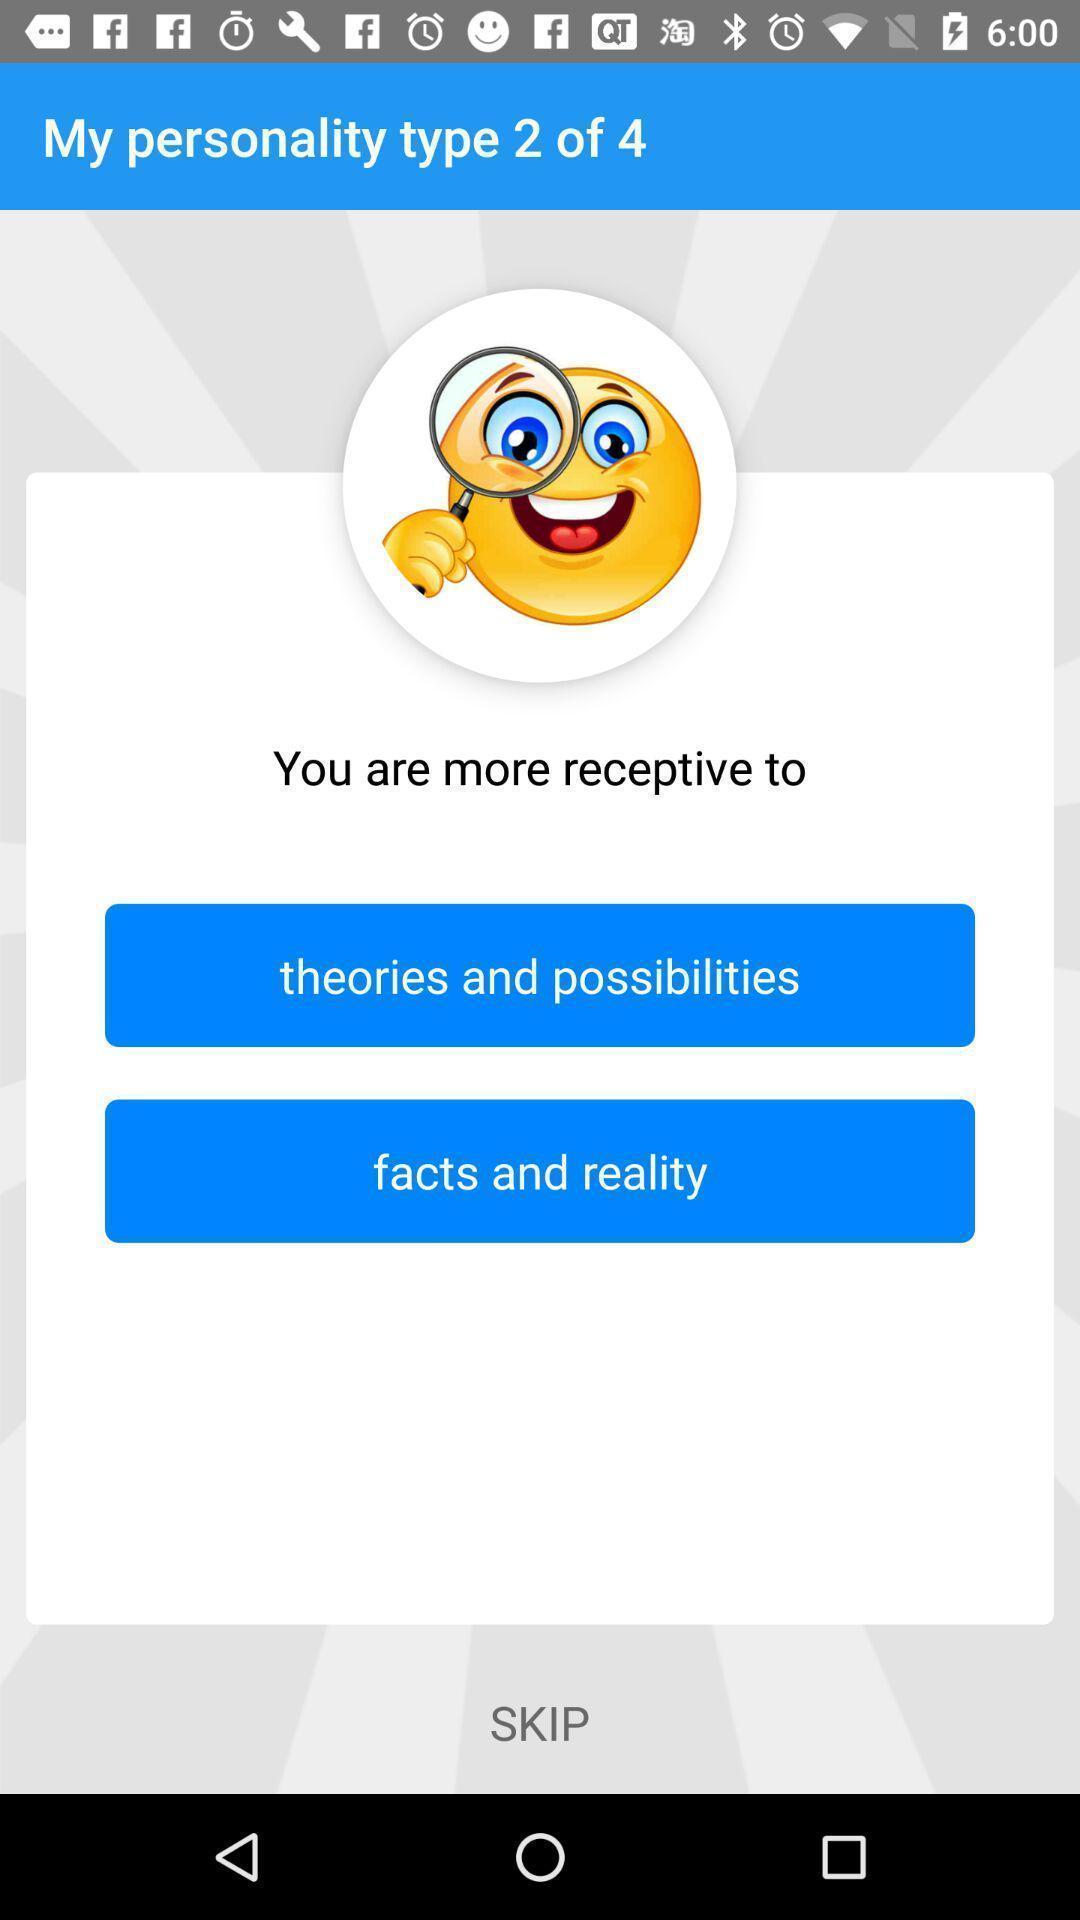Summarize the information in this screenshot. Page displaying few options and an emoji in social app. 